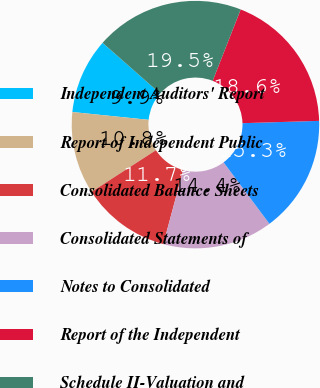<chart> <loc_0><loc_0><loc_500><loc_500><pie_chart><fcel>Independent Auditors' Report<fcel>Report of Independent Public<fcel>Consolidated Balance Sheets<fcel>Consolidated Statements of<fcel>Notes to Consolidated<fcel>Report of the Independent<fcel>Schedule II-Valuation and<nl><fcel>9.87%<fcel>10.77%<fcel>11.67%<fcel>14.38%<fcel>15.28%<fcel>18.56%<fcel>19.46%<nl></chart> 